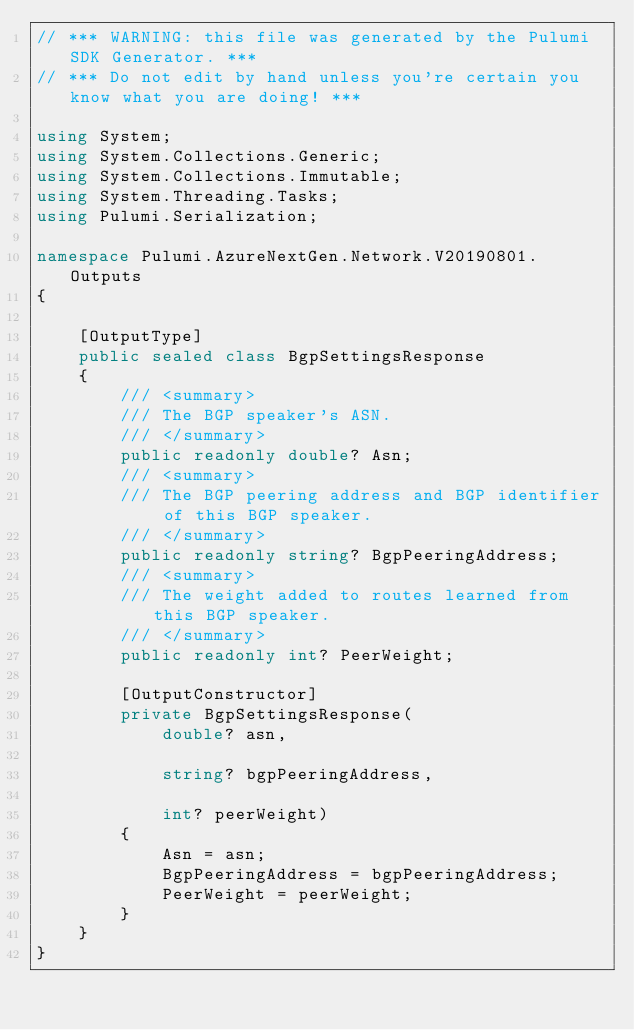<code> <loc_0><loc_0><loc_500><loc_500><_C#_>// *** WARNING: this file was generated by the Pulumi SDK Generator. ***
// *** Do not edit by hand unless you're certain you know what you are doing! ***

using System;
using System.Collections.Generic;
using System.Collections.Immutable;
using System.Threading.Tasks;
using Pulumi.Serialization;

namespace Pulumi.AzureNextGen.Network.V20190801.Outputs
{

    [OutputType]
    public sealed class BgpSettingsResponse
    {
        /// <summary>
        /// The BGP speaker's ASN.
        /// </summary>
        public readonly double? Asn;
        /// <summary>
        /// The BGP peering address and BGP identifier of this BGP speaker.
        /// </summary>
        public readonly string? BgpPeeringAddress;
        /// <summary>
        /// The weight added to routes learned from this BGP speaker.
        /// </summary>
        public readonly int? PeerWeight;

        [OutputConstructor]
        private BgpSettingsResponse(
            double? asn,

            string? bgpPeeringAddress,

            int? peerWeight)
        {
            Asn = asn;
            BgpPeeringAddress = bgpPeeringAddress;
            PeerWeight = peerWeight;
        }
    }
}
</code> 